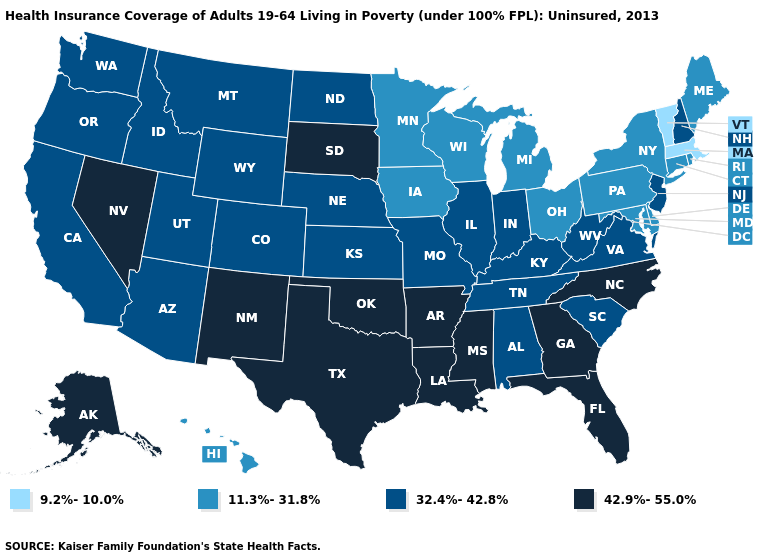Does Nevada have the highest value in the USA?
Give a very brief answer. Yes. Name the states that have a value in the range 32.4%-42.8%?
Short answer required. Alabama, Arizona, California, Colorado, Idaho, Illinois, Indiana, Kansas, Kentucky, Missouri, Montana, Nebraska, New Hampshire, New Jersey, North Dakota, Oregon, South Carolina, Tennessee, Utah, Virginia, Washington, West Virginia, Wyoming. What is the value of Hawaii?
Short answer required. 11.3%-31.8%. Does Vermont have the lowest value in the USA?
Write a very short answer. Yes. Name the states that have a value in the range 32.4%-42.8%?
Concise answer only. Alabama, Arizona, California, Colorado, Idaho, Illinois, Indiana, Kansas, Kentucky, Missouri, Montana, Nebraska, New Hampshire, New Jersey, North Dakota, Oregon, South Carolina, Tennessee, Utah, Virginia, Washington, West Virginia, Wyoming. What is the value of West Virginia?
Be succinct. 32.4%-42.8%. Among the states that border Oklahoma , which have the highest value?
Give a very brief answer. Arkansas, New Mexico, Texas. What is the value of Kentucky?
Answer briefly. 32.4%-42.8%. Name the states that have a value in the range 42.9%-55.0%?
Keep it brief. Alaska, Arkansas, Florida, Georgia, Louisiana, Mississippi, Nevada, New Mexico, North Carolina, Oklahoma, South Dakota, Texas. Does West Virginia have a higher value than Montana?
Short answer required. No. What is the lowest value in the South?
Quick response, please. 11.3%-31.8%. Among the states that border Maine , which have the lowest value?
Short answer required. New Hampshire. Name the states that have a value in the range 9.2%-10.0%?
Be succinct. Massachusetts, Vermont. What is the lowest value in states that border Ohio?
Give a very brief answer. 11.3%-31.8%. 